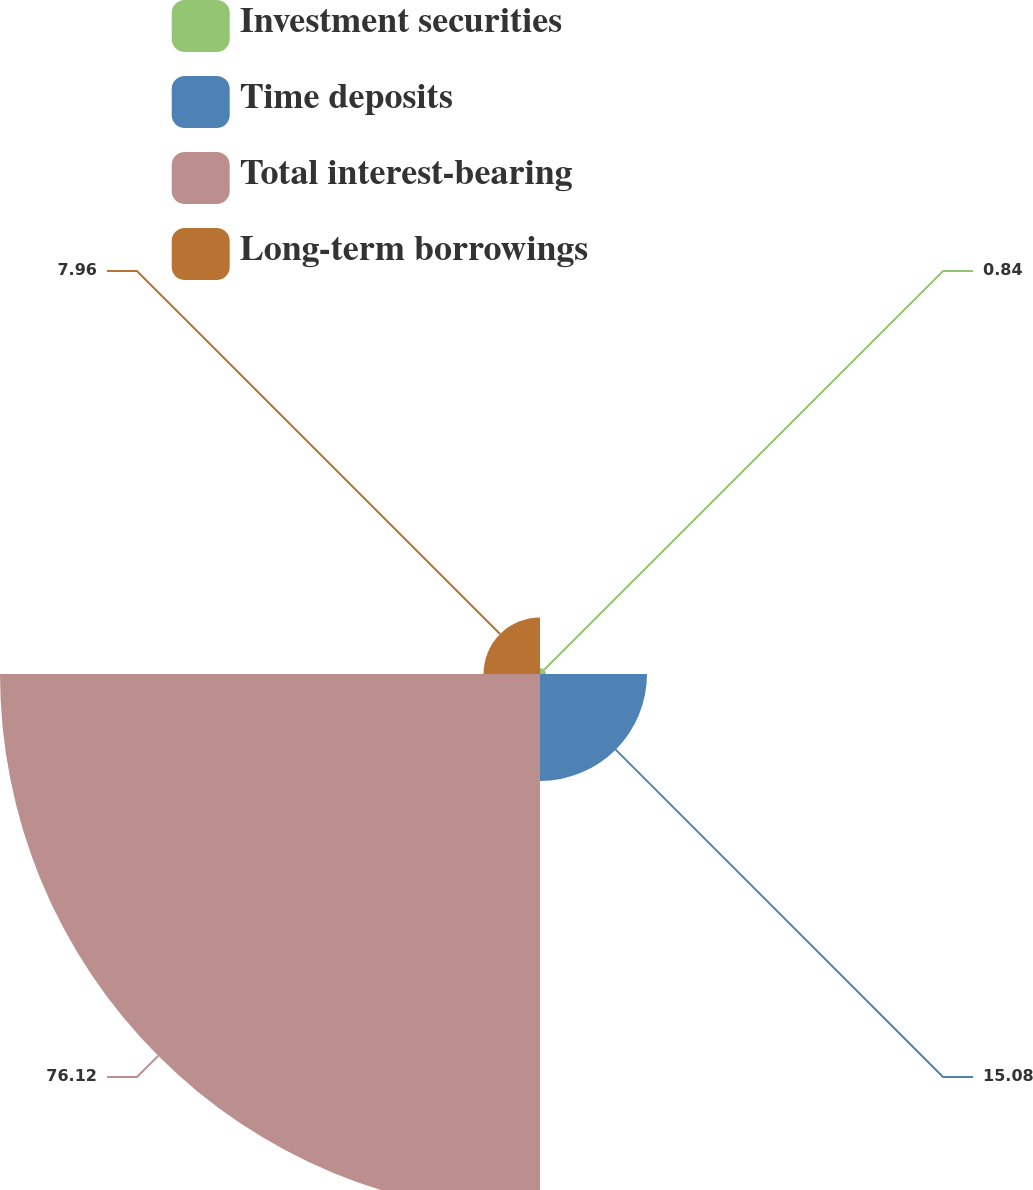<chart> <loc_0><loc_0><loc_500><loc_500><pie_chart><fcel>Investment securities<fcel>Time deposits<fcel>Total interest-bearing<fcel>Long-term borrowings<nl><fcel>0.84%<fcel>15.08%<fcel>76.11%<fcel>7.96%<nl></chart> 